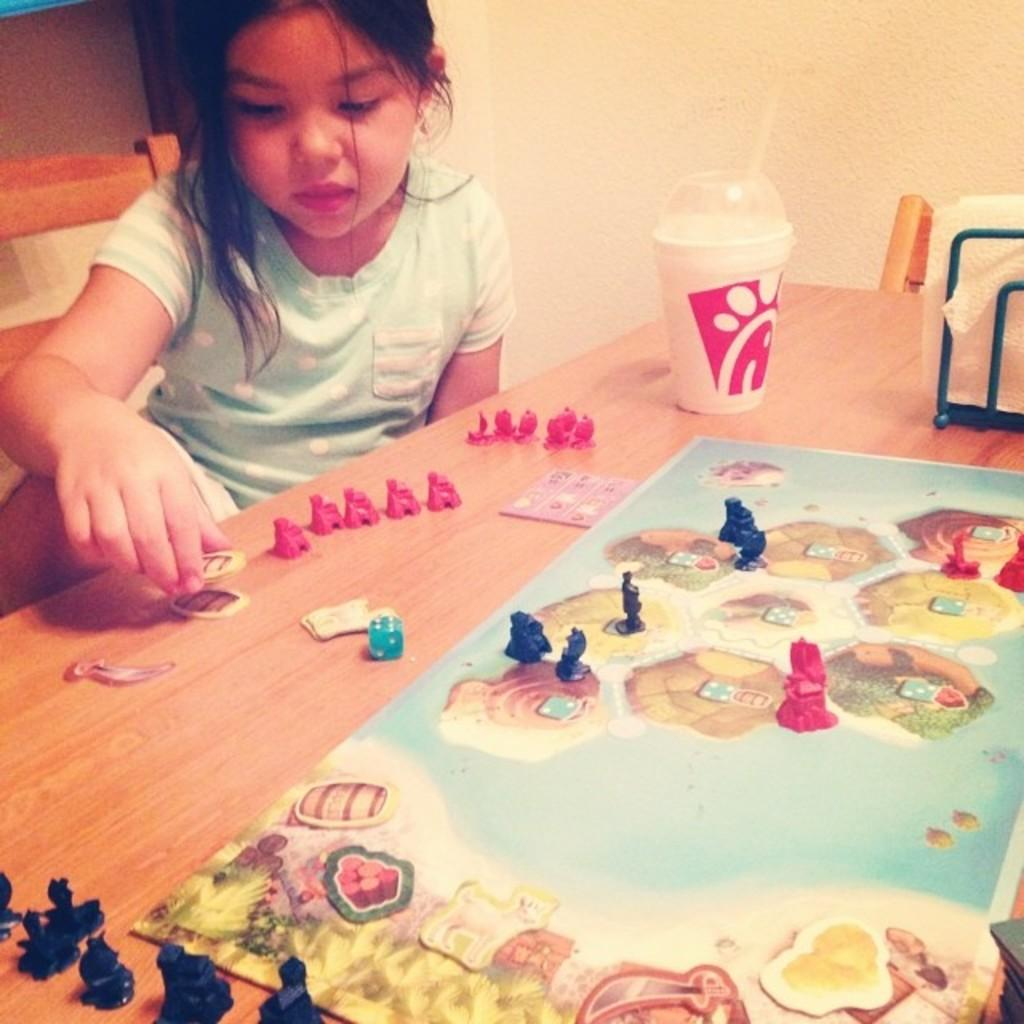Who is present in the image? There is a girl in the image. What object can be seen in the background? There is a table in the image. What items are on the table? There are toys and a cup on the table. What type of crate is visible in the image? There is no crate present in the image. Can you describe the view from the girl's perspective in the image? The provided facts do not give enough information to describe the view from the girl's perspective. 